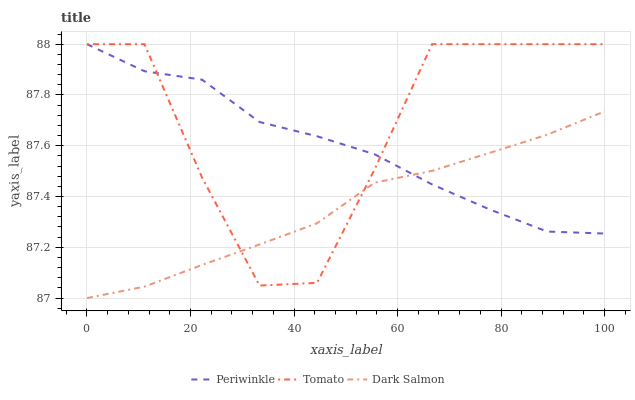Does Dark Salmon have the minimum area under the curve?
Answer yes or no. Yes. Does Tomato have the maximum area under the curve?
Answer yes or no. Yes. Does Periwinkle have the minimum area under the curve?
Answer yes or no. No. Does Periwinkle have the maximum area under the curve?
Answer yes or no. No. Is Dark Salmon the smoothest?
Answer yes or no. Yes. Is Tomato the roughest?
Answer yes or no. Yes. Is Periwinkle the smoothest?
Answer yes or no. No. Is Periwinkle the roughest?
Answer yes or no. No. Does Dark Salmon have the lowest value?
Answer yes or no. Yes. Does Periwinkle have the lowest value?
Answer yes or no. No. Does Periwinkle have the highest value?
Answer yes or no. Yes. Does Dark Salmon have the highest value?
Answer yes or no. No. Does Tomato intersect Dark Salmon?
Answer yes or no. Yes. Is Tomato less than Dark Salmon?
Answer yes or no. No. Is Tomato greater than Dark Salmon?
Answer yes or no. No. 